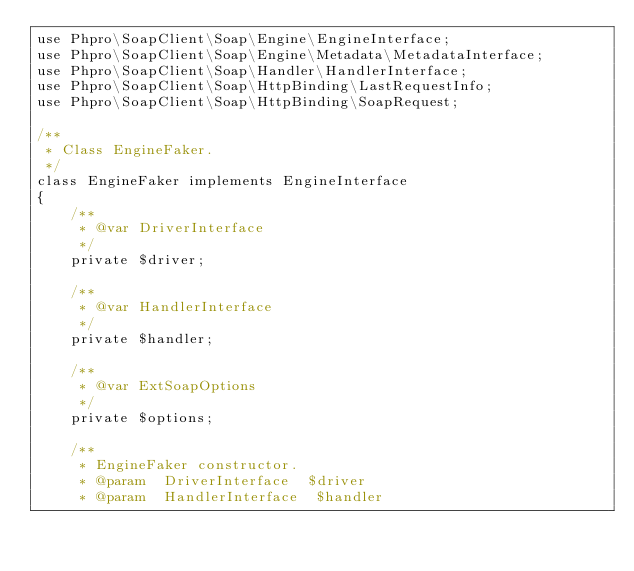Convert code to text. <code><loc_0><loc_0><loc_500><loc_500><_PHP_>use Phpro\SoapClient\Soap\Engine\EngineInterface;
use Phpro\SoapClient\Soap\Engine\Metadata\MetadataInterface;
use Phpro\SoapClient\Soap\Handler\HandlerInterface;
use Phpro\SoapClient\Soap\HttpBinding\LastRequestInfo;
use Phpro\SoapClient\Soap\HttpBinding\SoapRequest;

/**
 * Class EngineFaker.
 */
class EngineFaker implements EngineInterface
{
    /**
     * @var DriverInterface
     */
    private $driver;

    /**
     * @var HandlerInterface
     */
    private $handler;

    /**
     * @var ExtSoapOptions
     */
    private $options;

    /**
     * EngineFaker constructor.
     * @param  DriverInterface  $driver
     * @param  HandlerInterface  $handler</code> 